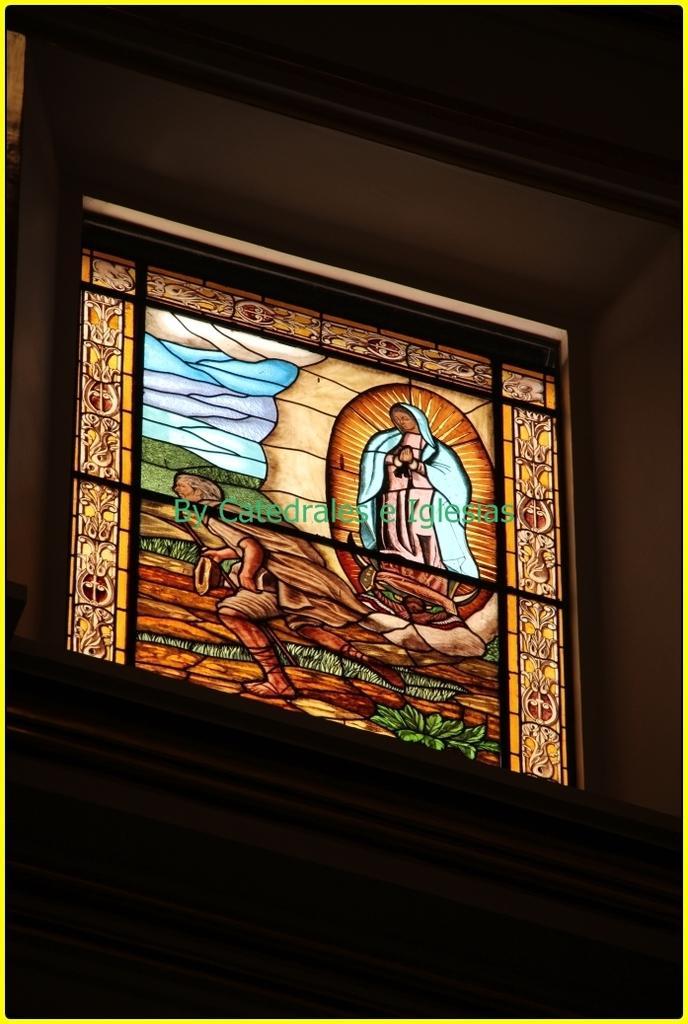How would you summarize this image in a sentence or two? It is a glass window, there is the painting of human, trees. 